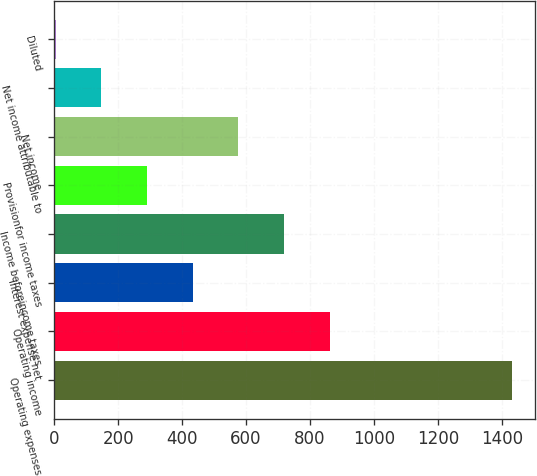Convert chart. <chart><loc_0><loc_0><loc_500><loc_500><bar_chart><fcel>Operating expenses<fcel>Operating income<fcel>Interest expense net<fcel>Income beforeincome taxes<fcel>Provisionfor income taxes<fcel>Net income<fcel>Net income attributable to<fcel>Diluted<nl><fcel>1433.5<fcel>861.78<fcel>432.99<fcel>718.85<fcel>290.06<fcel>575.92<fcel>147.13<fcel>4.2<nl></chart> 